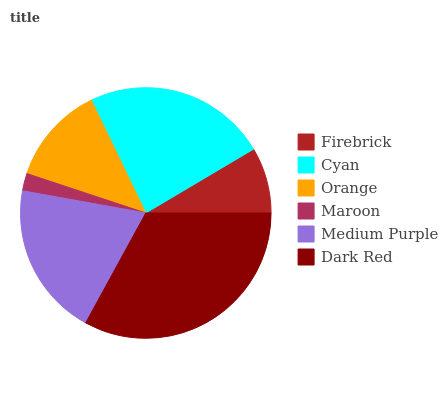Is Maroon the minimum?
Answer yes or no. Yes. Is Dark Red the maximum?
Answer yes or no. Yes. Is Cyan the minimum?
Answer yes or no. No. Is Cyan the maximum?
Answer yes or no. No. Is Cyan greater than Firebrick?
Answer yes or no. Yes. Is Firebrick less than Cyan?
Answer yes or no. Yes. Is Firebrick greater than Cyan?
Answer yes or no. No. Is Cyan less than Firebrick?
Answer yes or no. No. Is Medium Purple the high median?
Answer yes or no. Yes. Is Orange the low median?
Answer yes or no. Yes. Is Orange the high median?
Answer yes or no. No. Is Firebrick the low median?
Answer yes or no. No. 